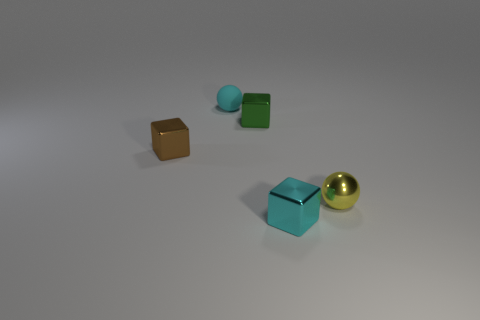Subtract all tiny brown blocks. How many blocks are left? 2 Add 1 big gray rubber balls. How many objects exist? 6 Subtract all blue cubes. Subtract all cyan cylinders. How many cubes are left? 3 Add 5 green cubes. How many green cubes are left? 6 Add 3 yellow objects. How many yellow objects exist? 4 Subtract 0 yellow cylinders. How many objects are left? 5 Subtract all blocks. How many objects are left? 2 Subtract all green blocks. Subtract all brown objects. How many objects are left? 3 